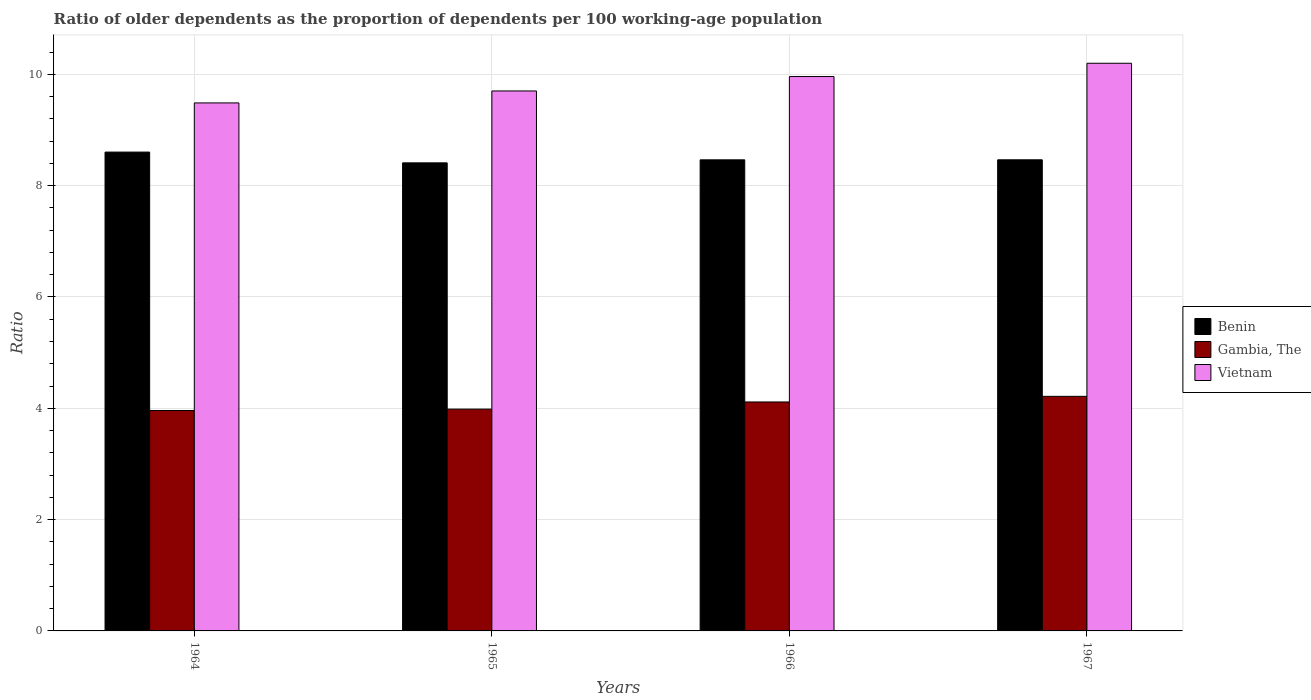Are the number of bars on each tick of the X-axis equal?
Keep it short and to the point. Yes. How many bars are there on the 2nd tick from the right?
Offer a very short reply. 3. What is the label of the 3rd group of bars from the left?
Your answer should be very brief. 1966. In how many cases, is the number of bars for a given year not equal to the number of legend labels?
Offer a terse response. 0. What is the age dependency ratio(old) in Vietnam in 1966?
Offer a terse response. 9.96. Across all years, what is the maximum age dependency ratio(old) in Benin?
Ensure brevity in your answer.  8.6. Across all years, what is the minimum age dependency ratio(old) in Vietnam?
Your answer should be compact. 9.49. In which year was the age dependency ratio(old) in Vietnam maximum?
Offer a terse response. 1967. In which year was the age dependency ratio(old) in Vietnam minimum?
Give a very brief answer. 1964. What is the total age dependency ratio(old) in Gambia, The in the graph?
Provide a succinct answer. 16.27. What is the difference between the age dependency ratio(old) in Vietnam in 1964 and that in 1965?
Provide a succinct answer. -0.21. What is the difference between the age dependency ratio(old) in Vietnam in 1966 and the age dependency ratio(old) in Gambia, The in 1967?
Your response must be concise. 5.75. What is the average age dependency ratio(old) in Benin per year?
Keep it short and to the point. 8.49. In the year 1964, what is the difference between the age dependency ratio(old) in Gambia, The and age dependency ratio(old) in Vietnam?
Offer a terse response. -5.53. What is the ratio of the age dependency ratio(old) in Vietnam in 1965 to that in 1967?
Provide a short and direct response. 0.95. Is the age dependency ratio(old) in Gambia, The in 1965 less than that in 1967?
Your answer should be compact. Yes. Is the difference between the age dependency ratio(old) in Gambia, The in 1966 and 1967 greater than the difference between the age dependency ratio(old) in Vietnam in 1966 and 1967?
Ensure brevity in your answer.  Yes. What is the difference between the highest and the second highest age dependency ratio(old) in Benin?
Your answer should be compact. 0.14. What is the difference between the highest and the lowest age dependency ratio(old) in Gambia, The?
Ensure brevity in your answer.  0.25. What does the 1st bar from the left in 1965 represents?
Provide a succinct answer. Benin. What does the 1st bar from the right in 1964 represents?
Your answer should be very brief. Vietnam. Is it the case that in every year, the sum of the age dependency ratio(old) in Benin and age dependency ratio(old) in Gambia, The is greater than the age dependency ratio(old) in Vietnam?
Your answer should be compact. Yes. Are all the bars in the graph horizontal?
Your response must be concise. No. How many years are there in the graph?
Make the answer very short. 4. What is the difference between two consecutive major ticks on the Y-axis?
Provide a succinct answer. 2. Are the values on the major ticks of Y-axis written in scientific E-notation?
Make the answer very short. No. Does the graph contain any zero values?
Your answer should be compact. No. Does the graph contain grids?
Your answer should be very brief. Yes. How many legend labels are there?
Make the answer very short. 3. How are the legend labels stacked?
Keep it short and to the point. Vertical. What is the title of the graph?
Keep it short and to the point. Ratio of older dependents as the proportion of dependents per 100 working-age population. Does "Rwanda" appear as one of the legend labels in the graph?
Offer a very short reply. No. What is the label or title of the X-axis?
Provide a short and direct response. Years. What is the label or title of the Y-axis?
Provide a short and direct response. Ratio. What is the Ratio of Benin in 1964?
Your answer should be very brief. 8.6. What is the Ratio in Gambia, The in 1964?
Give a very brief answer. 3.96. What is the Ratio of Vietnam in 1964?
Offer a very short reply. 9.49. What is the Ratio of Benin in 1965?
Your answer should be very brief. 8.41. What is the Ratio of Gambia, The in 1965?
Make the answer very short. 3.99. What is the Ratio in Vietnam in 1965?
Your answer should be compact. 9.7. What is the Ratio of Benin in 1966?
Offer a terse response. 8.46. What is the Ratio in Gambia, The in 1966?
Your response must be concise. 4.11. What is the Ratio in Vietnam in 1966?
Offer a terse response. 9.96. What is the Ratio in Benin in 1967?
Make the answer very short. 8.46. What is the Ratio in Gambia, The in 1967?
Your answer should be compact. 4.21. What is the Ratio in Vietnam in 1967?
Your response must be concise. 10.2. Across all years, what is the maximum Ratio in Benin?
Offer a terse response. 8.6. Across all years, what is the maximum Ratio in Gambia, The?
Offer a very short reply. 4.21. Across all years, what is the maximum Ratio of Vietnam?
Provide a succinct answer. 10.2. Across all years, what is the minimum Ratio in Benin?
Provide a short and direct response. 8.41. Across all years, what is the minimum Ratio in Gambia, The?
Your answer should be compact. 3.96. Across all years, what is the minimum Ratio of Vietnam?
Your response must be concise. 9.49. What is the total Ratio of Benin in the graph?
Your answer should be very brief. 33.94. What is the total Ratio in Gambia, The in the graph?
Offer a terse response. 16.27. What is the total Ratio of Vietnam in the graph?
Offer a terse response. 39.35. What is the difference between the Ratio of Benin in 1964 and that in 1965?
Ensure brevity in your answer.  0.19. What is the difference between the Ratio in Gambia, The in 1964 and that in 1965?
Your answer should be compact. -0.03. What is the difference between the Ratio of Vietnam in 1964 and that in 1965?
Keep it short and to the point. -0.21. What is the difference between the Ratio of Benin in 1964 and that in 1966?
Make the answer very short. 0.14. What is the difference between the Ratio in Gambia, The in 1964 and that in 1966?
Your answer should be compact. -0.15. What is the difference between the Ratio of Vietnam in 1964 and that in 1966?
Give a very brief answer. -0.47. What is the difference between the Ratio in Benin in 1964 and that in 1967?
Your answer should be compact. 0.14. What is the difference between the Ratio of Gambia, The in 1964 and that in 1967?
Provide a succinct answer. -0.25. What is the difference between the Ratio of Vietnam in 1964 and that in 1967?
Keep it short and to the point. -0.71. What is the difference between the Ratio of Benin in 1965 and that in 1966?
Ensure brevity in your answer.  -0.05. What is the difference between the Ratio in Gambia, The in 1965 and that in 1966?
Your answer should be compact. -0.13. What is the difference between the Ratio in Vietnam in 1965 and that in 1966?
Offer a terse response. -0.26. What is the difference between the Ratio of Benin in 1965 and that in 1967?
Provide a short and direct response. -0.05. What is the difference between the Ratio of Gambia, The in 1965 and that in 1967?
Provide a succinct answer. -0.23. What is the difference between the Ratio in Vietnam in 1965 and that in 1967?
Offer a terse response. -0.5. What is the difference between the Ratio in Benin in 1966 and that in 1967?
Your answer should be compact. -0. What is the difference between the Ratio in Gambia, The in 1966 and that in 1967?
Offer a very short reply. -0.1. What is the difference between the Ratio of Vietnam in 1966 and that in 1967?
Provide a short and direct response. -0.24. What is the difference between the Ratio of Benin in 1964 and the Ratio of Gambia, The in 1965?
Provide a succinct answer. 4.62. What is the difference between the Ratio in Benin in 1964 and the Ratio in Vietnam in 1965?
Offer a very short reply. -1.1. What is the difference between the Ratio of Gambia, The in 1964 and the Ratio of Vietnam in 1965?
Provide a succinct answer. -5.74. What is the difference between the Ratio of Benin in 1964 and the Ratio of Gambia, The in 1966?
Your response must be concise. 4.49. What is the difference between the Ratio in Benin in 1964 and the Ratio in Vietnam in 1966?
Give a very brief answer. -1.36. What is the difference between the Ratio of Gambia, The in 1964 and the Ratio of Vietnam in 1966?
Give a very brief answer. -6. What is the difference between the Ratio in Benin in 1964 and the Ratio in Gambia, The in 1967?
Your answer should be compact. 4.39. What is the difference between the Ratio in Benin in 1964 and the Ratio in Vietnam in 1967?
Provide a succinct answer. -1.6. What is the difference between the Ratio in Gambia, The in 1964 and the Ratio in Vietnam in 1967?
Ensure brevity in your answer.  -6.24. What is the difference between the Ratio of Benin in 1965 and the Ratio of Gambia, The in 1966?
Ensure brevity in your answer.  4.3. What is the difference between the Ratio in Benin in 1965 and the Ratio in Vietnam in 1966?
Provide a succinct answer. -1.55. What is the difference between the Ratio of Gambia, The in 1965 and the Ratio of Vietnam in 1966?
Provide a succinct answer. -5.98. What is the difference between the Ratio in Benin in 1965 and the Ratio in Gambia, The in 1967?
Offer a very short reply. 4.19. What is the difference between the Ratio in Benin in 1965 and the Ratio in Vietnam in 1967?
Offer a terse response. -1.79. What is the difference between the Ratio in Gambia, The in 1965 and the Ratio in Vietnam in 1967?
Your answer should be very brief. -6.21. What is the difference between the Ratio of Benin in 1966 and the Ratio of Gambia, The in 1967?
Provide a short and direct response. 4.25. What is the difference between the Ratio in Benin in 1966 and the Ratio in Vietnam in 1967?
Your answer should be compact. -1.74. What is the difference between the Ratio of Gambia, The in 1966 and the Ratio of Vietnam in 1967?
Your answer should be compact. -6.09. What is the average Ratio in Benin per year?
Your response must be concise. 8.49. What is the average Ratio of Gambia, The per year?
Your answer should be very brief. 4.07. What is the average Ratio of Vietnam per year?
Give a very brief answer. 9.84. In the year 1964, what is the difference between the Ratio in Benin and Ratio in Gambia, The?
Make the answer very short. 4.64. In the year 1964, what is the difference between the Ratio in Benin and Ratio in Vietnam?
Keep it short and to the point. -0.88. In the year 1964, what is the difference between the Ratio in Gambia, The and Ratio in Vietnam?
Your answer should be compact. -5.53. In the year 1965, what is the difference between the Ratio in Benin and Ratio in Gambia, The?
Provide a succinct answer. 4.42. In the year 1965, what is the difference between the Ratio of Benin and Ratio of Vietnam?
Offer a very short reply. -1.29. In the year 1965, what is the difference between the Ratio of Gambia, The and Ratio of Vietnam?
Your answer should be very brief. -5.72. In the year 1966, what is the difference between the Ratio in Benin and Ratio in Gambia, The?
Keep it short and to the point. 4.35. In the year 1966, what is the difference between the Ratio of Benin and Ratio of Vietnam?
Ensure brevity in your answer.  -1.5. In the year 1966, what is the difference between the Ratio of Gambia, The and Ratio of Vietnam?
Make the answer very short. -5.85. In the year 1967, what is the difference between the Ratio of Benin and Ratio of Gambia, The?
Offer a terse response. 4.25. In the year 1967, what is the difference between the Ratio of Benin and Ratio of Vietnam?
Provide a short and direct response. -1.73. In the year 1967, what is the difference between the Ratio in Gambia, The and Ratio in Vietnam?
Make the answer very short. -5.98. What is the ratio of the Ratio in Gambia, The in 1964 to that in 1965?
Provide a short and direct response. 0.99. What is the ratio of the Ratio in Vietnam in 1964 to that in 1965?
Your answer should be compact. 0.98. What is the ratio of the Ratio of Benin in 1964 to that in 1966?
Your answer should be compact. 1.02. What is the ratio of the Ratio of Gambia, The in 1964 to that in 1966?
Your answer should be very brief. 0.96. What is the ratio of the Ratio of Benin in 1964 to that in 1967?
Offer a very short reply. 1.02. What is the ratio of the Ratio in Gambia, The in 1964 to that in 1967?
Your answer should be compact. 0.94. What is the ratio of the Ratio in Vietnam in 1964 to that in 1967?
Your answer should be very brief. 0.93. What is the ratio of the Ratio in Benin in 1965 to that in 1966?
Provide a succinct answer. 0.99. What is the ratio of the Ratio of Gambia, The in 1965 to that in 1966?
Your answer should be very brief. 0.97. What is the ratio of the Ratio in Benin in 1965 to that in 1967?
Make the answer very short. 0.99. What is the ratio of the Ratio of Gambia, The in 1965 to that in 1967?
Make the answer very short. 0.95. What is the ratio of the Ratio of Vietnam in 1965 to that in 1967?
Make the answer very short. 0.95. What is the ratio of the Ratio of Gambia, The in 1966 to that in 1967?
Provide a succinct answer. 0.98. What is the ratio of the Ratio in Vietnam in 1966 to that in 1967?
Give a very brief answer. 0.98. What is the difference between the highest and the second highest Ratio of Benin?
Offer a very short reply. 0.14. What is the difference between the highest and the second highest Ratio in Gambia, The?
Make the answer very short. 0.1. What is the difference between the highest and the second highest Ratio of Vietnam?
Your answer should be compact. 0.24. What is the difference between the highest and the lowest Ratio in Benin?
Give a very brief answer. 0.19. What is the difference between the highest and the lowest Ratio of Gambia, The?
Provide a short and direct response. 0.25. What is the difference between the highest and the lowest Ratio in Vietnam?
Make the answer very short. 0.71. 